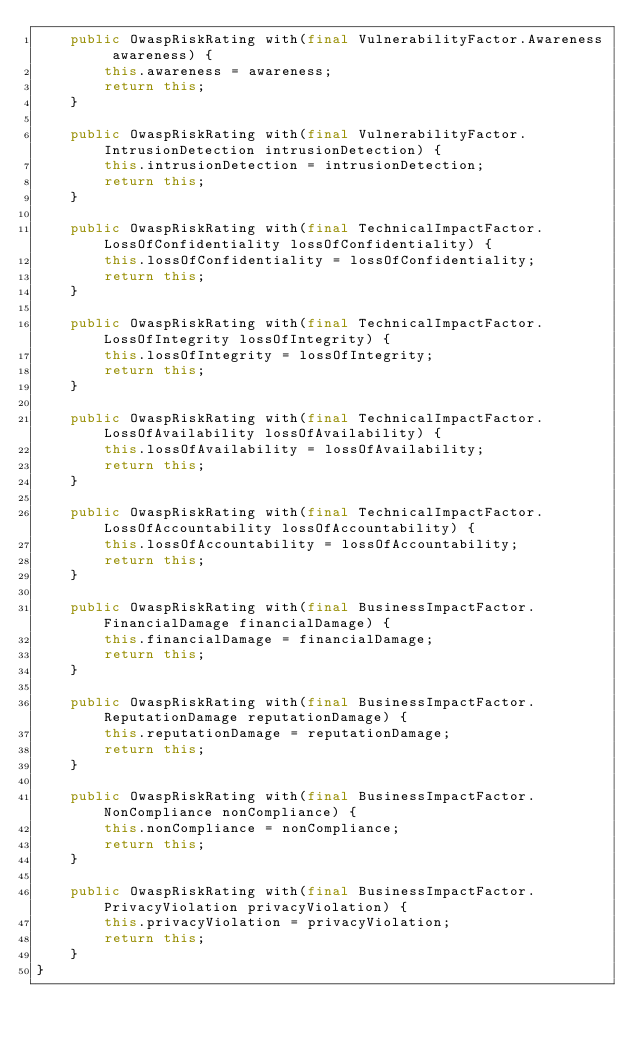<code> <loc_0><loc_0><loc_500><loc_500><_Java_>    public OwaspRiskRating with(final VulnerabilityFactor.Awareness awareness) {
        this.awareness = awareness;
        return this;
    }

    public OwaspRiskRating with(final VulnerabilityFactor.IntrusionDetection intrusionDetection) {
        this.intrusionDetection = intrusionDetection;
        return this;
    }

    public OwaspRiskRating with(final TechnicalImpactFactor.LossOfConfidentiality lossOfConfidentiality) {
        this.lossOfConfidentiality = lossOfConfidentiality;
        return this;
    }

    public OwaspRiskRating with(final TechnicalImpactFactor.LossOfIntegrity lossOfIntegrity) {
        this.lossOfIntegrity = lossOfIntegrity;
        return this;
    }

    public OwaspRiskRating with(final TechnicalImpactFactor.LossOfAvailability lossOfAvailability) {
        this.lossOfAvailability = lossOfAvailability;
        return this;
    }

    public OwaspRiskRating with(final TechnicalImpactFactor.LossOfAccountability lossOfAccountability) {
        this.lossOfAccountability = lossOfAccountability;
        return this;
    }

    public OwaspRiskRating with(final BusinessImpactFactor.FinancialDamage financialDamage) {
        this.financialDamage = financialDamage;
        return this;
    }

    public OwaspRiskRating with(final BusinessImpactFactor.ReputationDamage reputationDamage) {
        this.reputationDamage = reputationDamage;
        return this;
    }

    public OwaspRiskRating with(final BusinessImpactFactor.NonCompliance nonCompliance) {
        this.nonCompliance = nonCompliance;
        return this;
    }

    public OwaspRiskRating with(final BusinessImpactFactor.PrivacyViolation privacyViolation) {
        this.privacyViolation = privacyViolation;
        return this;
    }
}
</code> 